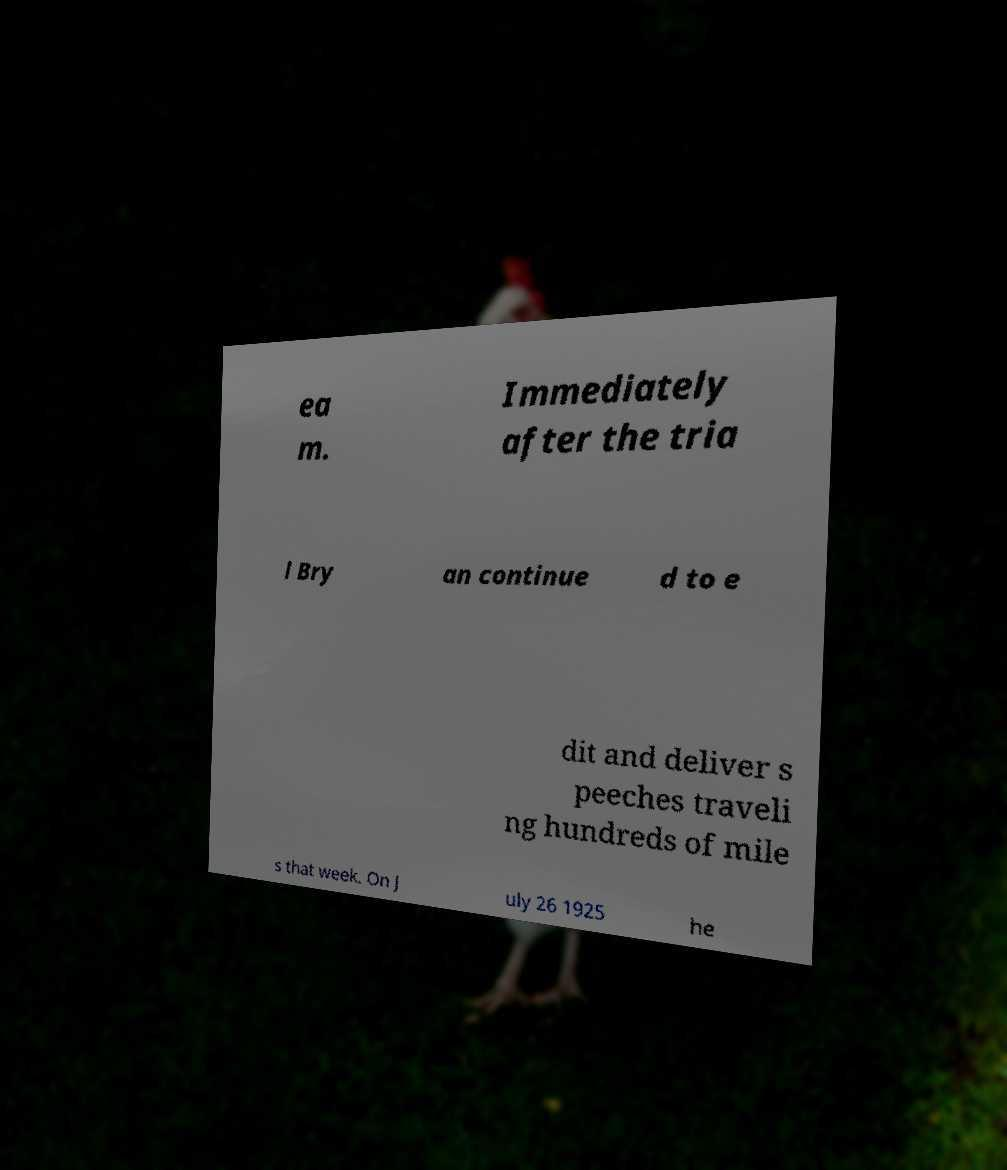Can you accurately transcribe the text from the provided image for me? ea m. Immediately after the tria l Bry an continue d to e dit and deliver s peeches traveli ng hundreds of mile s that week. On J uly 26 1925 he 